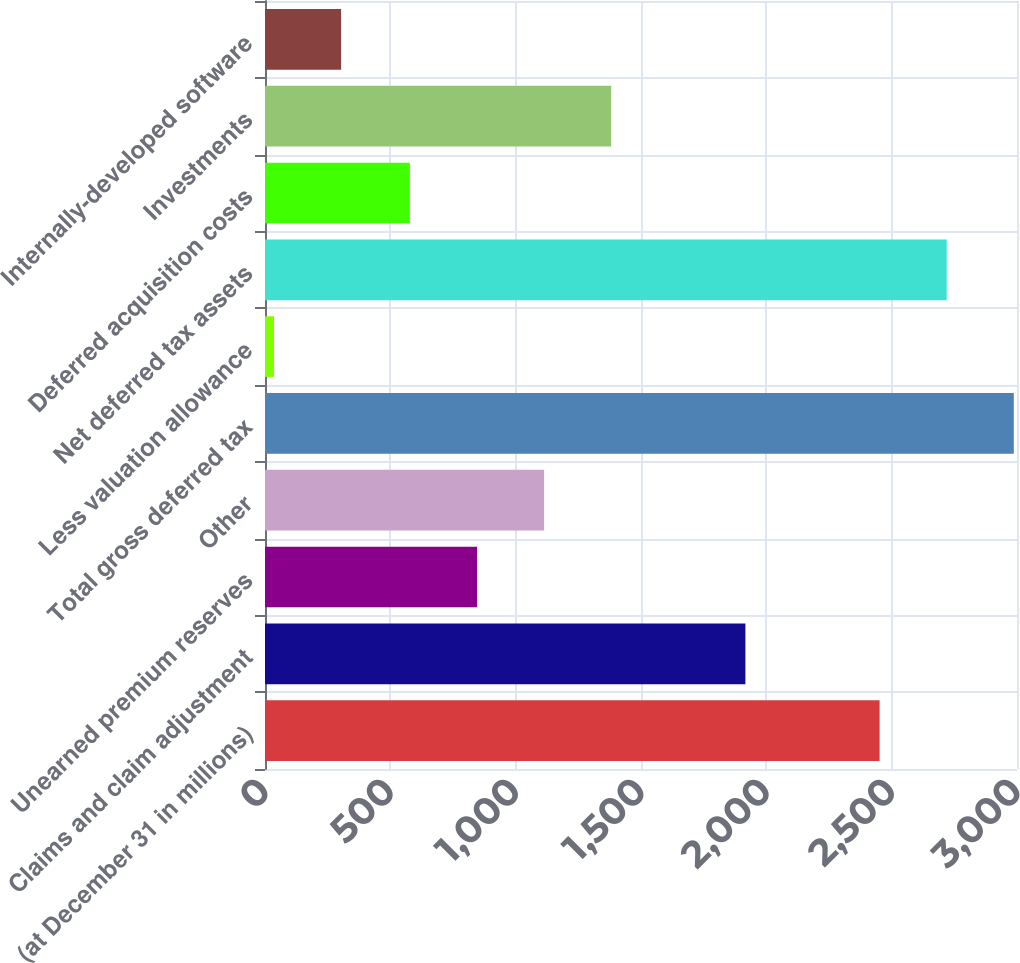Convert chart to OTSL. <chart><loc_0><loc_0><loc_500><loc_500><bar_chart><fcel>(at December 31 in millions)<fcel>Claims and claim adjustment<fcel>Unearned premium reserves<fcel>Other<fcel>Total gross deferred tax<fcel>Less valuation allowance<fcel>Net deferred tax assets<fcel>Deferred acquisition costs<fcel>Investments<fcel>Internally-developed software<nl><fcel>2451.9<fcel>1916.5<fcel>845.7<fcel>1113.4<fcel>2987.3<fcel>36<fcel>2719.6<fcel>578<fcel>1381.1<fcel>303.7<nl></chart> 